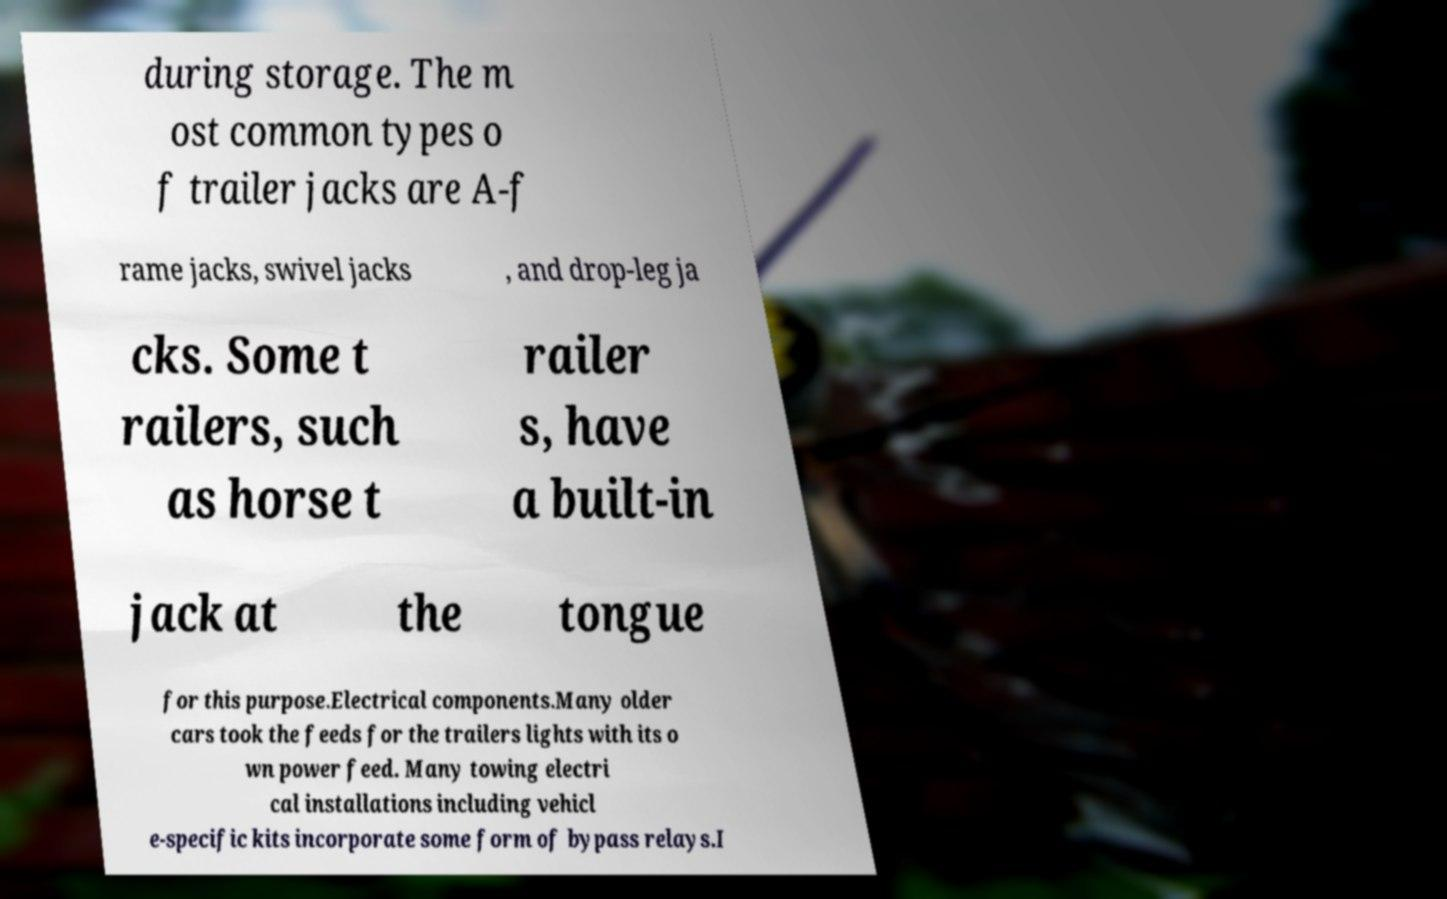Please identify and transcribe the text found in this image. during storage. The m ost common types o f trailer jacks are A-f rame jacks, swivel jacks , and drop-leg ja cks. Some t railers, such as horse t railer s, have a built-in jack at the tongue for this purpose.Electrical components.Many older cars took the feeds for the trailers lights with its o wn power feed. Many towing electri cal installations including vehicl e-specific kits incorporate some form of bypass relays.I 